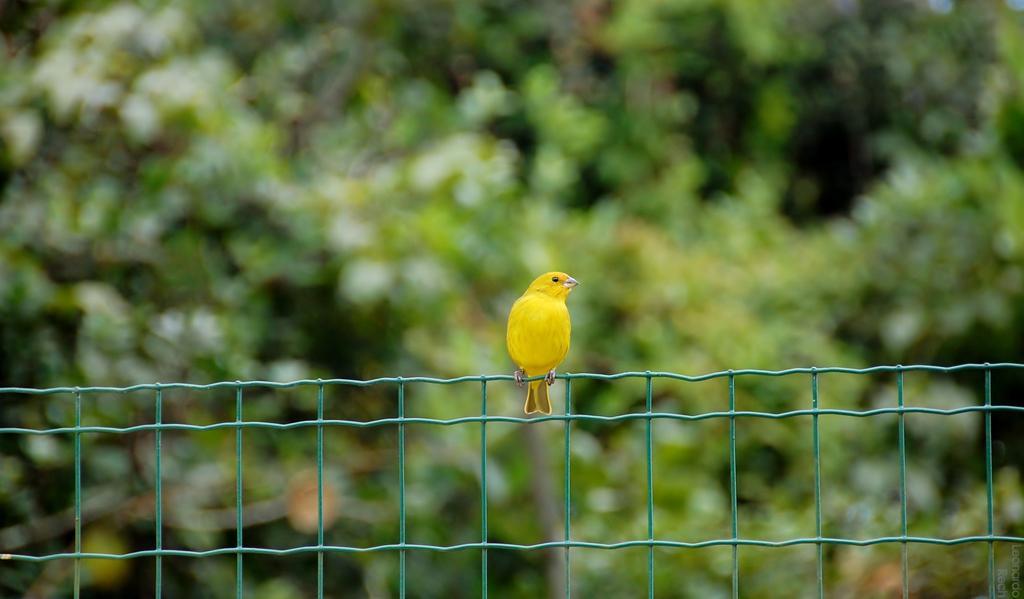Could you give a brief overview of what you see in this image? In this image we can see a bird on the metal fence. On the backside we can see some trees. 